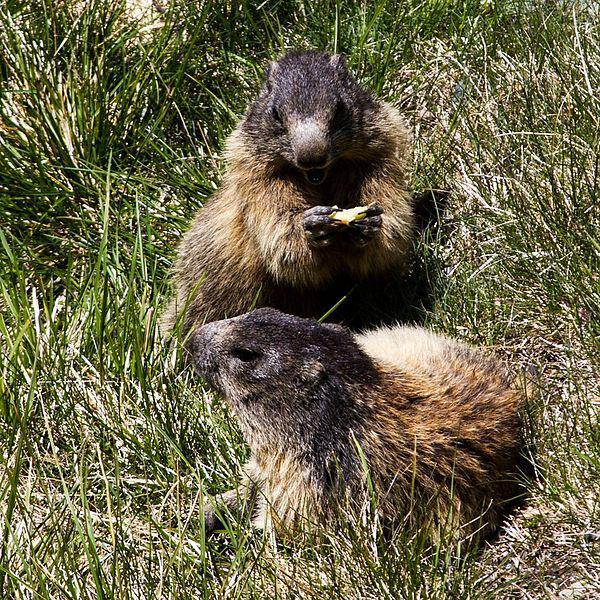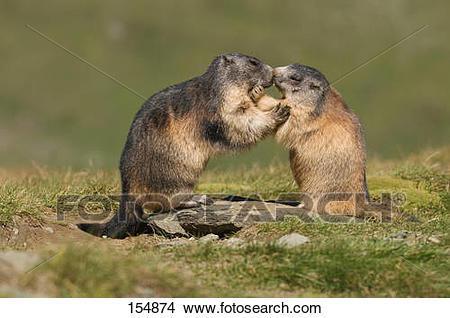The first image is the image on the left, the second image is the image on the right. For the images displayed, is the sentence "There is three rodents." factually correct? Answer yes or no. No. The first image is the image on the left, the second image is the image on the right. Considering the images on both sides, is "There are three marmots" valid? Answer yes or no. No. 